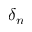<formula> <loc_0><loc_0><loc_500><loc_500>\delta _ { n }</formula> 